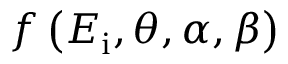<formula> <loc_0><loc_0><loc_500><loc_500>f \left ( E _ { i } , \theta , \alpha , \beta \right )</formula> 